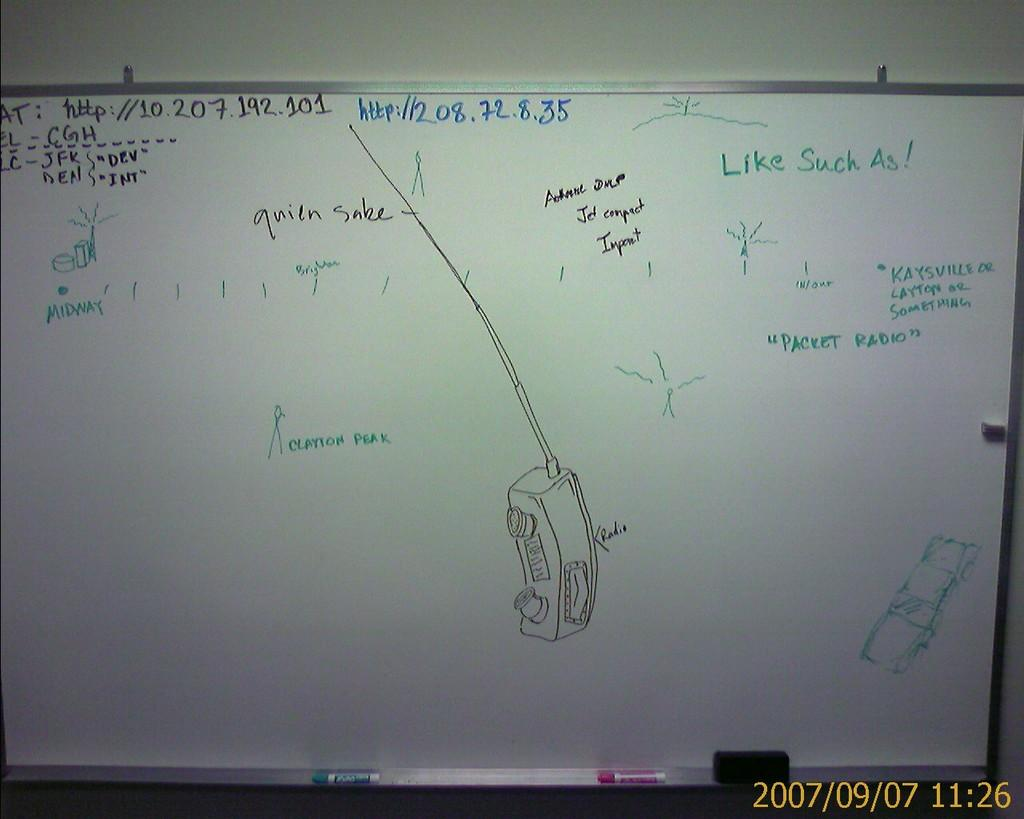<image>
Describe the image concisely. A whiteboard with sketches and annotations such as Clayton Peak. 